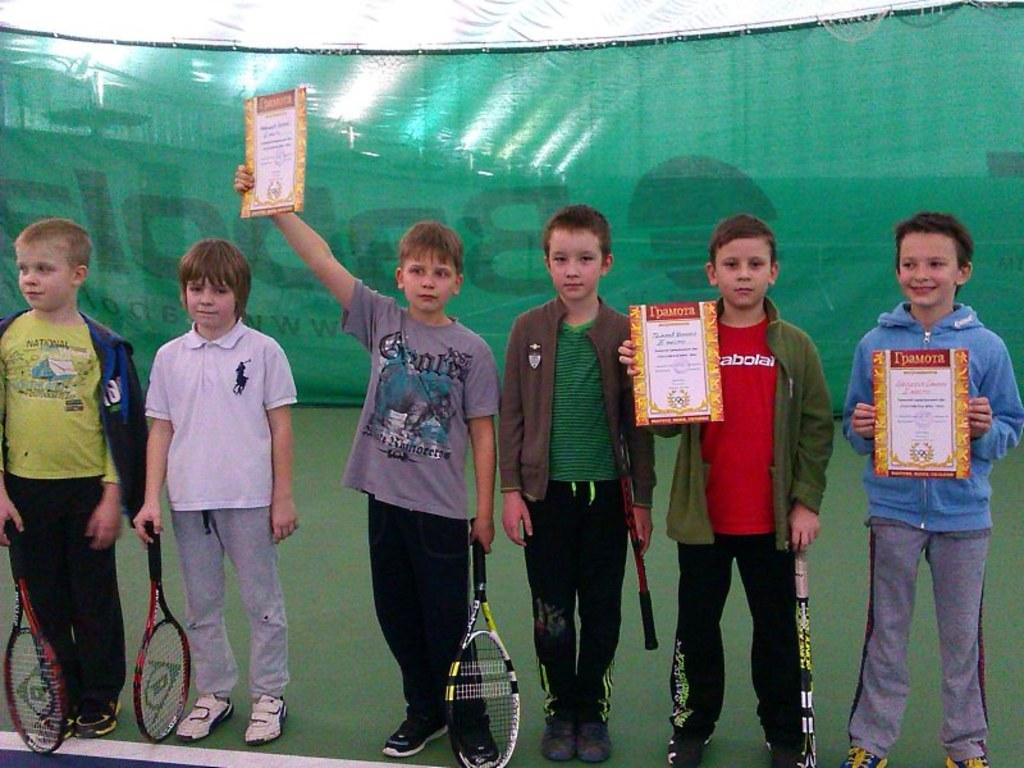How many boys are present in the image? There are six boys in the image. What are the boys doing in the image? The boys are standing in the image. What objects are the boys holding? The boys are holding tennis rackets in the image. Is there any additional item held by one of the boys? Yes, one of the boys is holding a memorandum in his hand. What type of argument is the frog having with the boys in the image? There is no frog present in the image, so there cannot be an argument between the boys and a frog. 